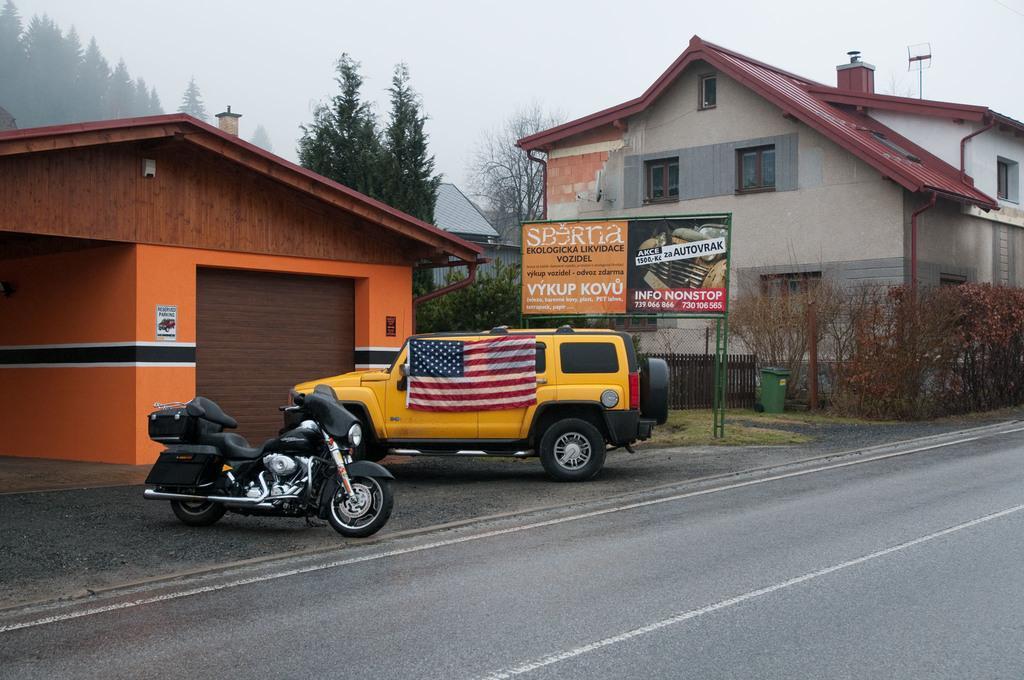Could you give a brief overview of what you see in this image? At the foreground of the image there is road on which there is motorcycle which is of black color and yellow color car to which a flag is attached and at the background of the image there are some houses, trees, board and clear sky. 